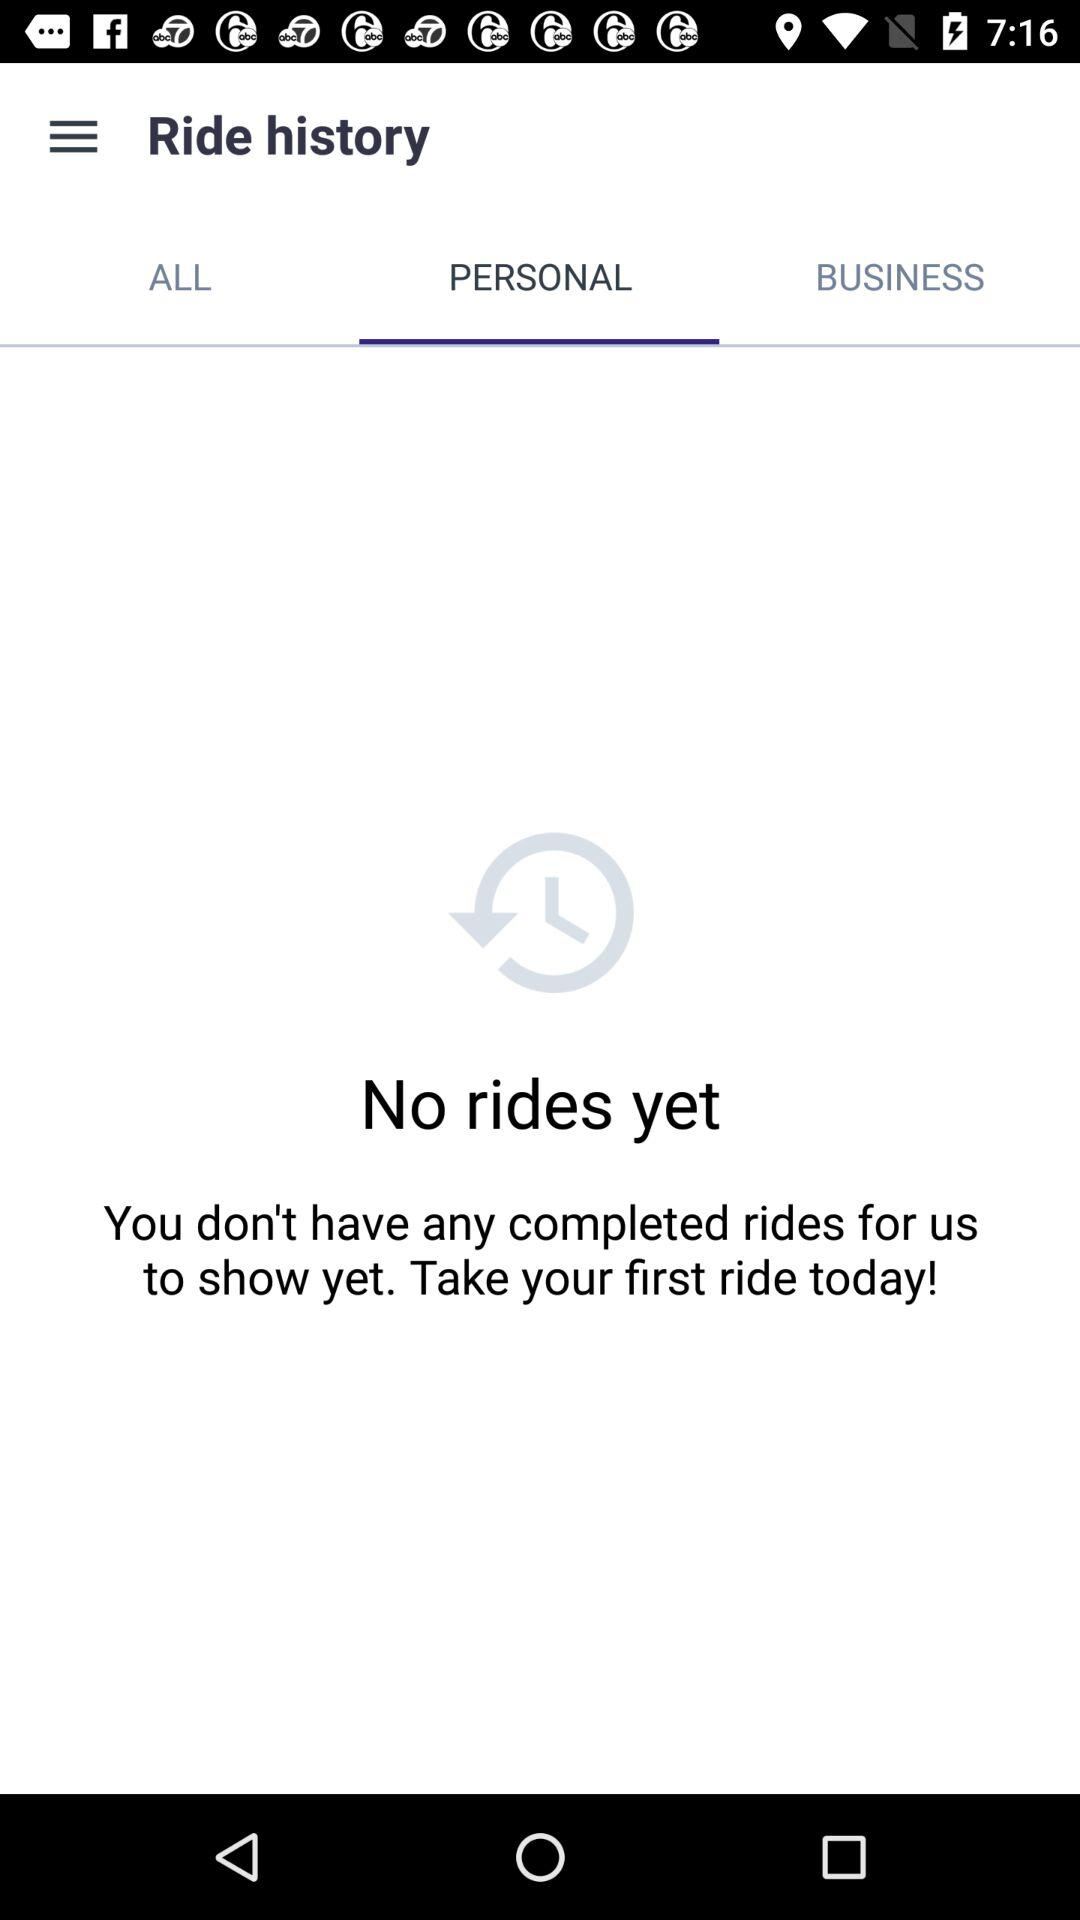Which tab is selected? The selected tab is "PERSONAL". 